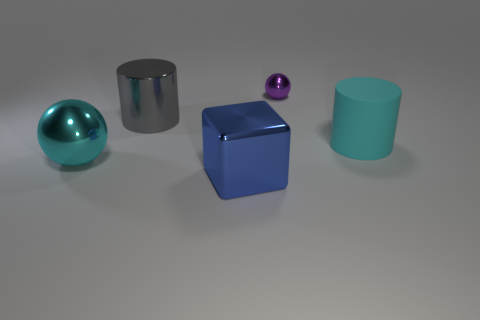Add 4 small purple things. How many objects exist? 9 Subtract all cylinders. How many objects are left? 3 Subtract all small metallic spheres. Subtract all large things. How many objects are left? 0 Add 1 big cyan rubber things. How many big cyan rubber things are left? 2 Add 2 cyan things. How many cyan things exist? 4 Subtract 0 purple blocks. How many objects are left? 5 